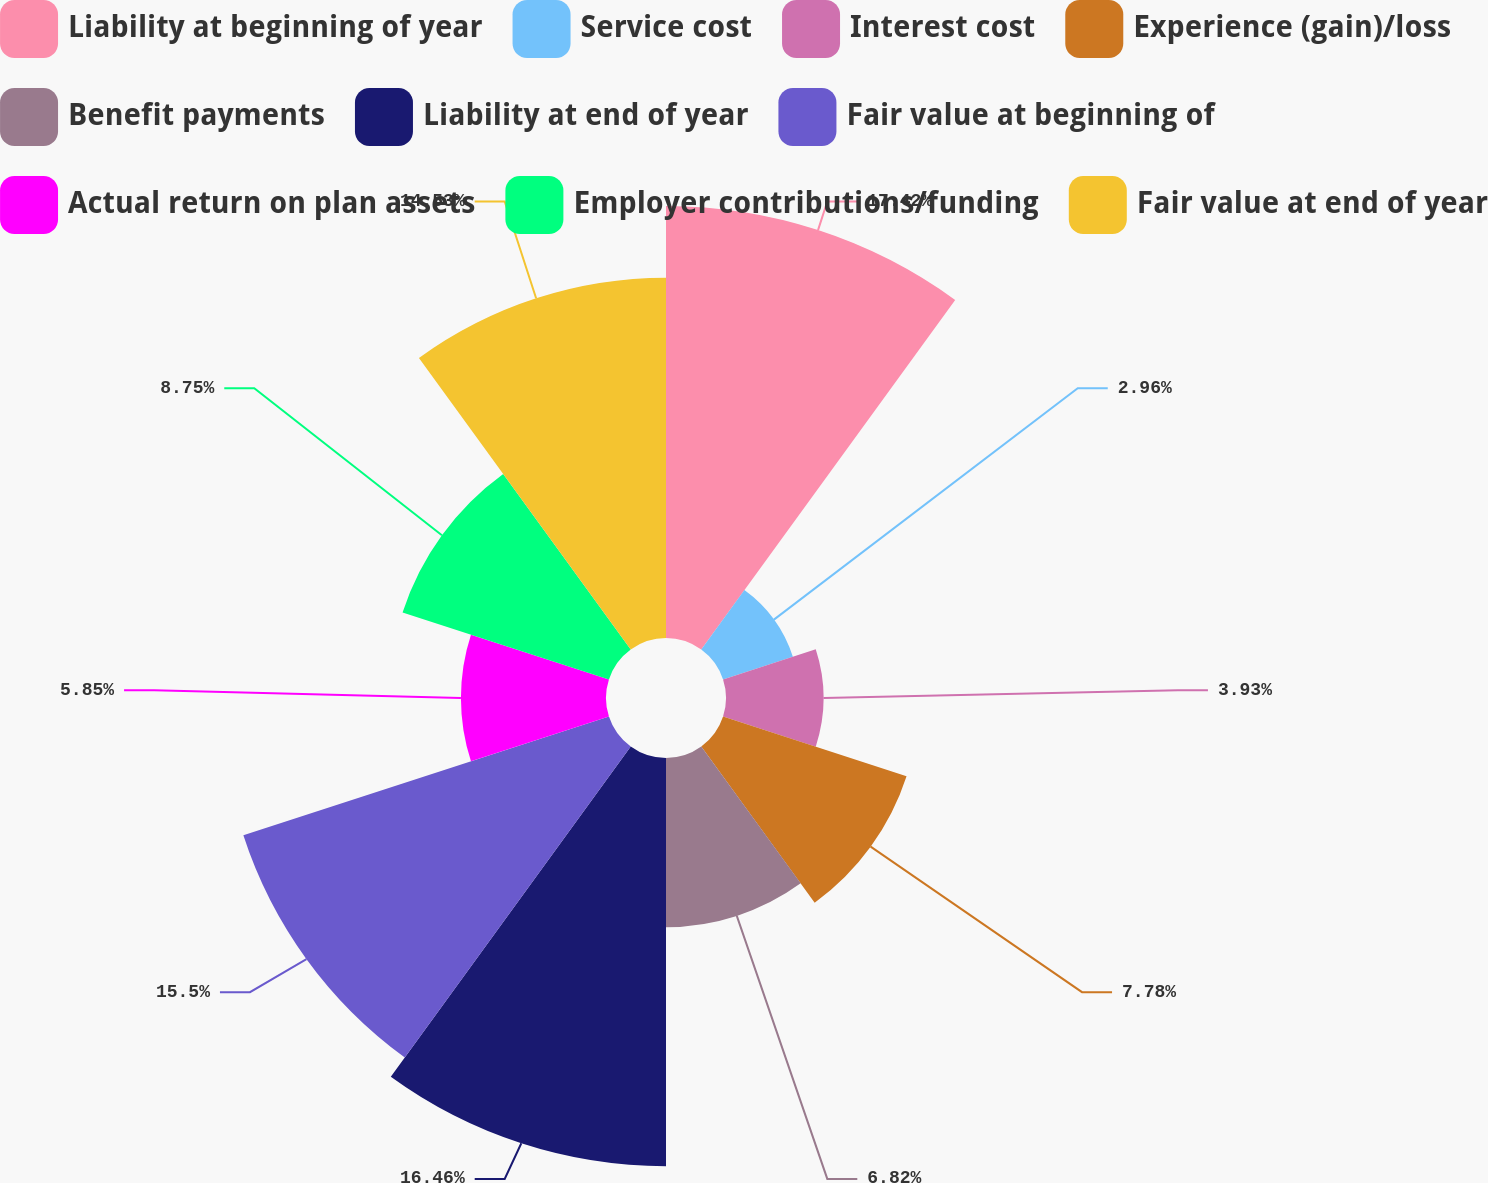Convert chart to OTSL. <chart><loc_0><loc_0><loc_500><loc_500><pie_chart><fcel>Liability at beginning of year<fcel>Service cost<fcel>Interest cost<fcel>Experience (gain)/loss<fcel>Benefit payments<fcel>Liability at end of year<fcel>Fair value at beginning of<fcel>Actual return on plan assets<fcel>Employer contributions/funding<fcel>Fair value at end of year<nl><fcel>17.42%<fcel>2.96%<fcel>3.93%<fcel>7.78%<fcel>6.82%<fcel>16.46%<fcel>15.5%<fcel>5.85%<fcel>8.75%<fcel>14.53%<nl></chart> 